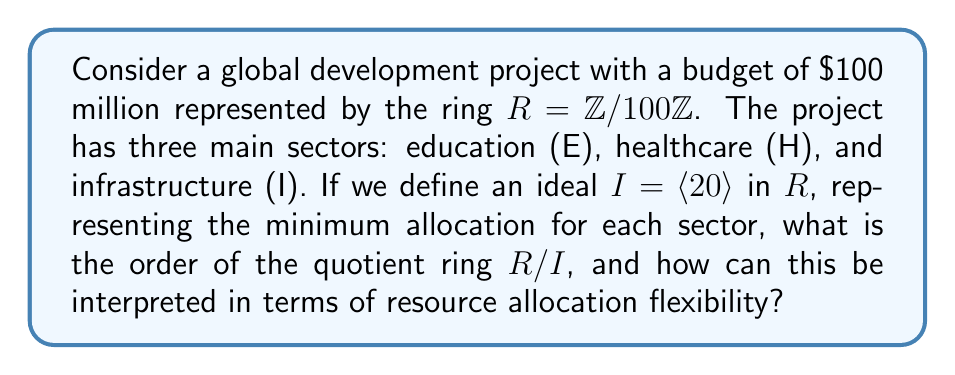Can you answer this question? To solve this problem, we'll follow these steps:

1) First, let's understand what the ring $R = \mathbb{Z}/100\mathbb{Z}$ represents. This is the ring of integers modulo 100, which aligns with our total budget of $100 million.

2) The ideal $I = \langle 20 \rangle$ represents all multiples of 20 in $R$. In the context of our problem, this means each sector must receive funding in multiples of $20 million.

3) To find the order of the quotient ring $R/I$, we need to determine how many cosets of $I$ are in $R$. This is equivalent to finding how many distinct remainders we get when dividing elements of $R$ by 20.

4) In $\mathbb{Z}/100\mathbb{Z}$, the possible remainders when dividing by 20 are 0, 1, 2, ..., 19.

5) Therefore, the order of $R/I$ is 20.

6) Interpreting this result:
   - Each element in $R/I$ represents a class of budget allocations that are equivalent modulo the minimum sector allocation.
   - The order 20 indicates that there are 20 distinct ways to allocate the budget while respecting the minimum sector allocation.

7) In terms of resource allocation flexibility:
   - The project managers have 20 distinct allocation strategies to choose from.
   - Each strategy differs by increments of $5 million (since 100/20 = 5).
   - For example, one strategy might be (20, 40, 40), another (25, 35, 40), and so on.

This quotient ring structure helps optimize resource allocation by ensuring a minimum allocation to each sector while providing a clear set of allocation options, simplifying the decision-making process in complex global development projects.
Answer: The order of the quotient ring $R/I$ is 20, which represents the number of distinct resource allocation strategies available to project managers while respecting the minimum sector allocation of $20 million. 